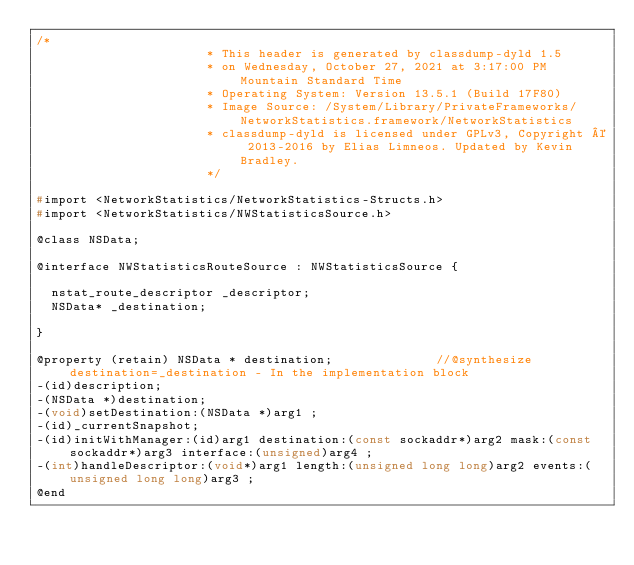<code> <loc_0><loc_0><loc_500><loc_500><_C_>/*
                       * This header is generated by classdump-dyld 1.5
                       * on Wednesday, October 27, 2021 at 3:17:00 PM Mountain Standard Time
                       * Operating System: Version 13.5.1 (Build 17F80)
                       * Image Source: /System/Library/PrivateFrameworks/NetworkStatistics.framework/NetworkStatistics
                       * classdump-dyld is licensed under GPLv3, Copyright © 2013-2016 by Elias Limneos. Updated by Kevin Bradley.
                       */

#import <NetworkStatistics/NetworkStatistics-Structs.h>
#import <NetworkStatistics/NWStatisticsSource.h>

@class NSData;

@interface NWStatisticsRouteSource : NWStatisticsSource {

	nstat_route_descriptor _descriptor;
	NSData* _destination;

}

@property (retain) NSData * destination;              //@synthesize destination=_destination - In the implementation block
-(id)description;
-(NSData *)destination;
-(void)setDestination:(NSData *)arg1 ;
-(id)_currentSnapshot;
-(id)initWithManager:(id)arg1 destination:(const sockaddr*)arg2 mask:(const sockaddr*)arg3 interface:(unsigned)arg4 ;
-(int)handleDescriptor:(void*)arg1 length:(unsigned long long)arg2 events:(unsigned long long)arg3 ;
@end

</code> 